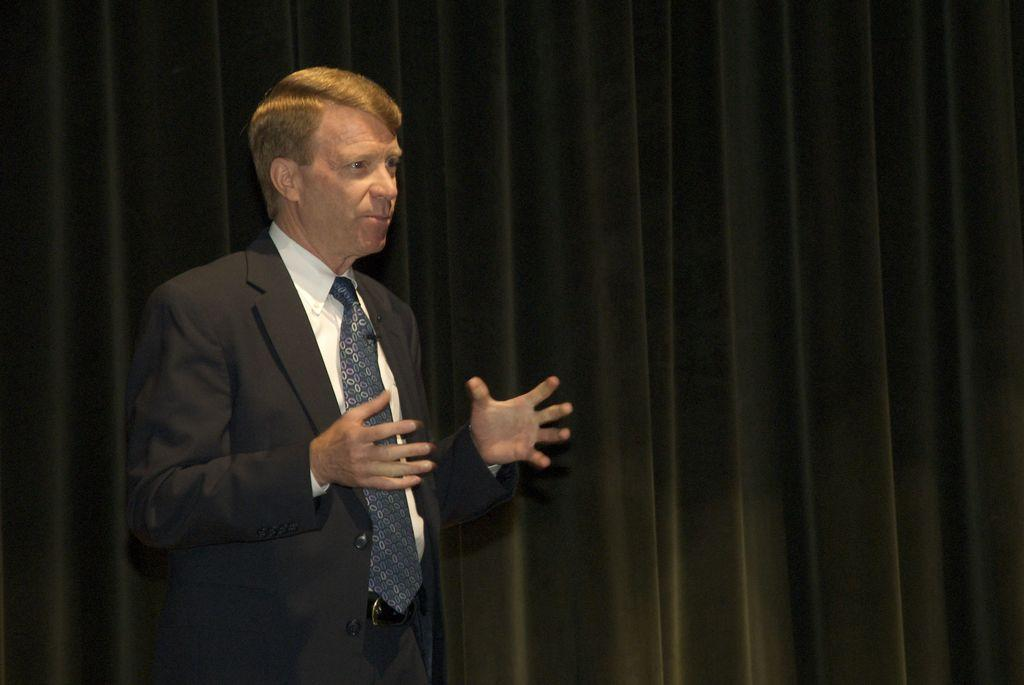What is the person in the image wearing? The person is wearing a black suit and a tie. What color is the curtain in the background? The curtain in the background is black. Is there any blood visible on the person's suit in the image? No, there is no blood visible on the person's suit in the image. 